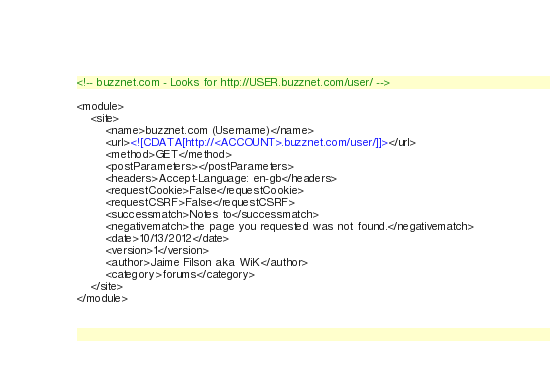Convert code to text. <code><loc_0><loc_0><loc_500><loc_500><_XML_><!-- buzznet.com - Looks for http://USER.buzznet.com/user/ -->

<module>
    <site>
        <name>buzznet.com (Username)</name>
        <url><![CDATA[http://<ACCOUNT>.buzznet.com/user/]]></url>
        <method>GET</method>
        <postParameters></postParameters>
        <headers>Accept-Language: en-gb</headers>
        <requestCookie>False</requestCookie>
        <requestCSRF>False</requestCSRF>
        <successmatch>Notes to</successmatch>
        <negativematch>the page you requested was not found.</negativematch>
        <date>10/13/2012</date>
        <version>1</version>
        <author>Jaime Filson aka WiK</author>
        <category>forums</category>
    </site>
</module></code> 